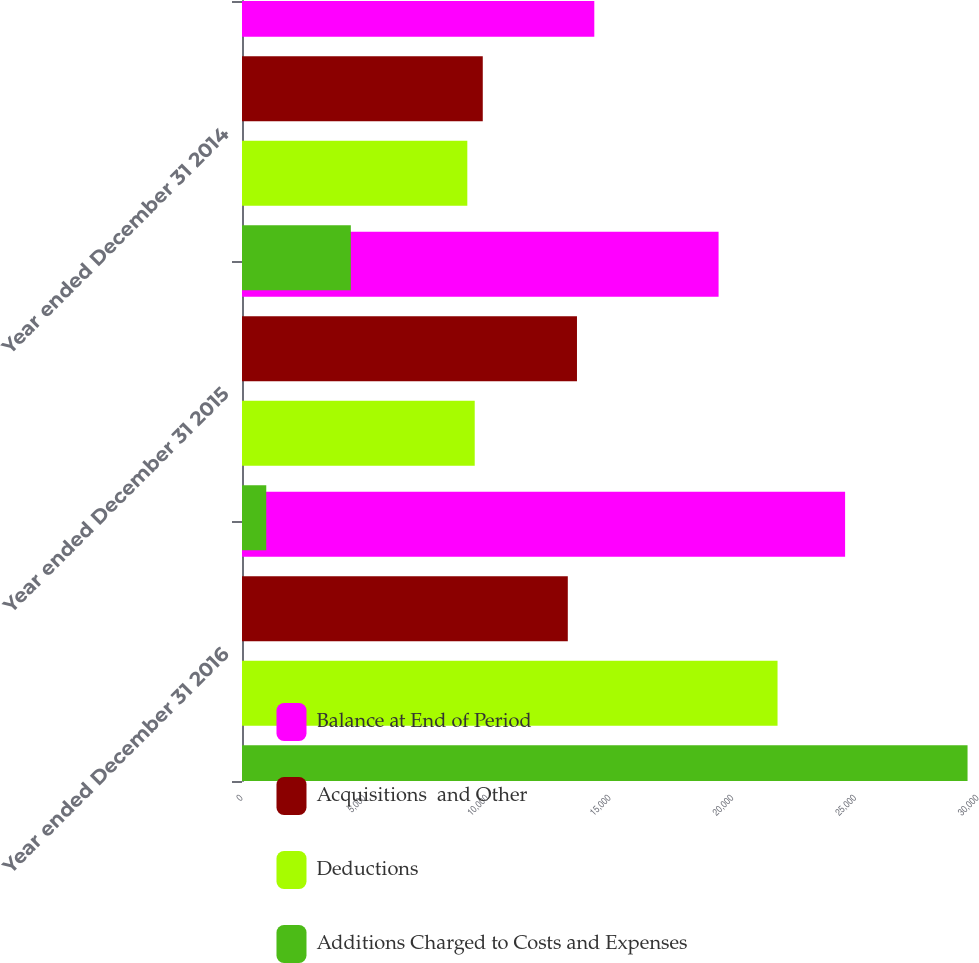<chart> <loc_0><loc_0><loc_500><loc_500><stacked_bar_chart><ecel><fcel>Year ended December 31 2016<fcel>Year ended December 31 2015<fcel>Year ended December 31 2014<nl><fcel>Balance at End of Period<fcel>24583<fcel>19426<fcel>14360<nl><fcel>Acquisitions  and Other<fcel>13280<fcel>13654<fcel>9814<nl><fcel>Deductions<fcel>21829<fcel>9486<fcel>9184<nl><fcel>Additions Charged to Costs and Expenses<fcel>29574<fcel>989<fcel>4436<nl></chart> 